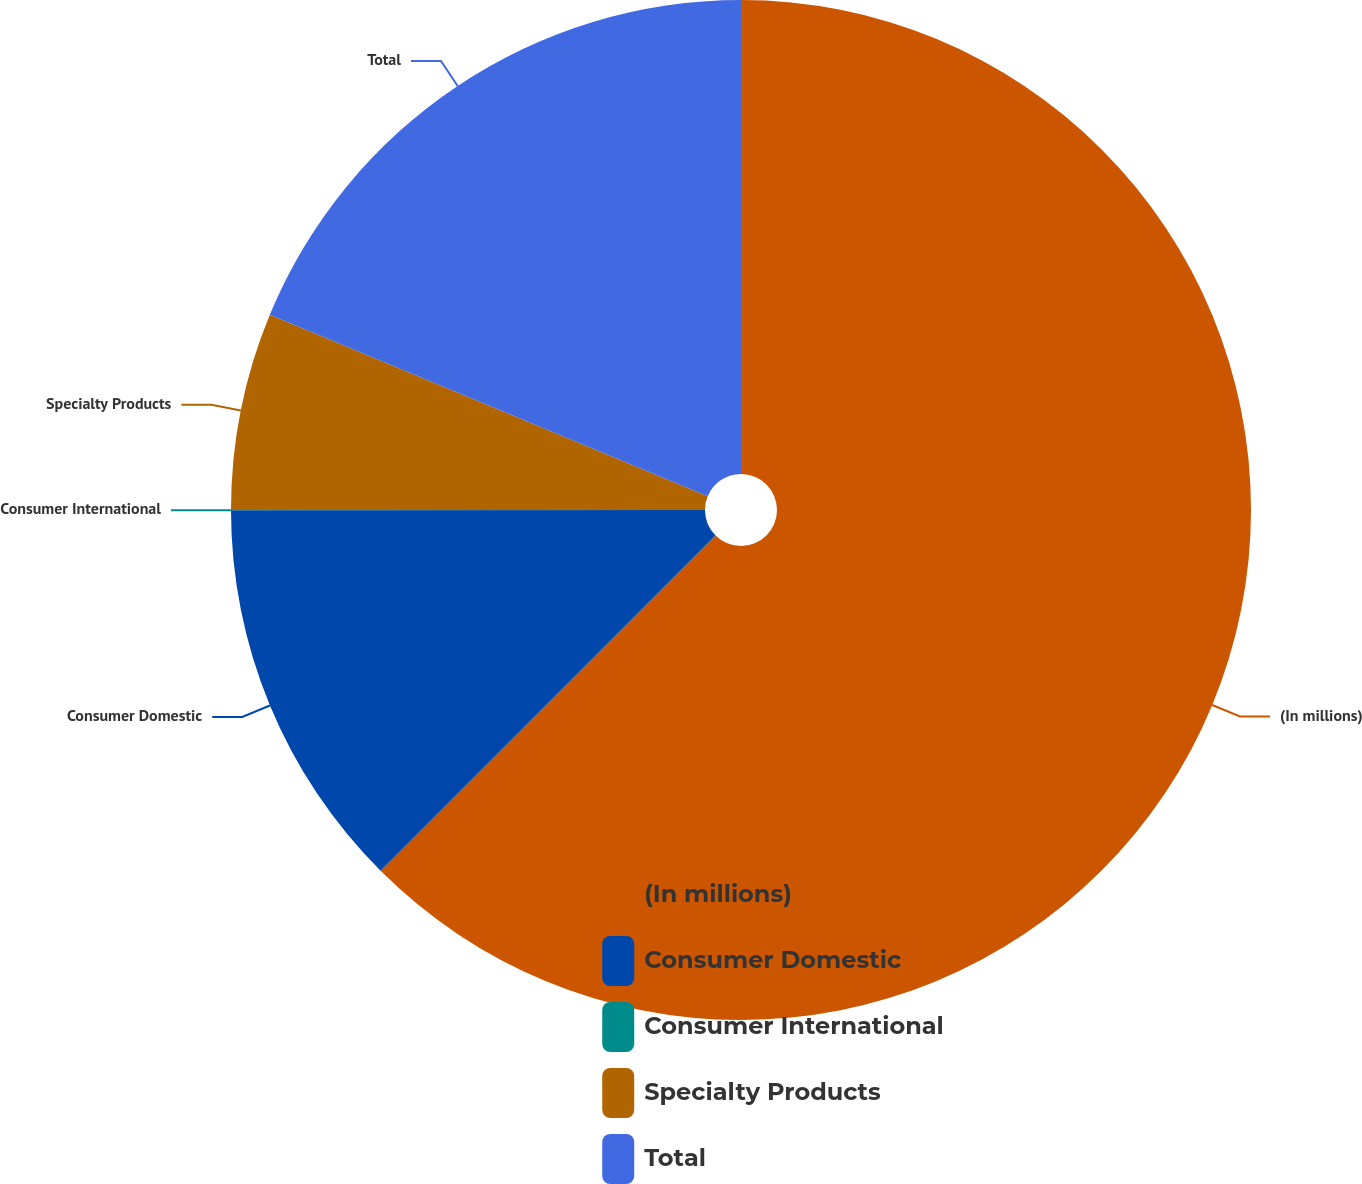Convert chart to OTSL. <chart><loc_0><loc_0><loc_500><loc_500><pie_chart><fcel>(In millions)<fcel>Consumer Domestic<fcel>Consumer International<fcel>Specialty Products<fcel>Total<nl><fcel>62.49%<fcel>12.5%<fcel>0.01%<fcel>6.25%<fcel>18.75%<nl></chart> 